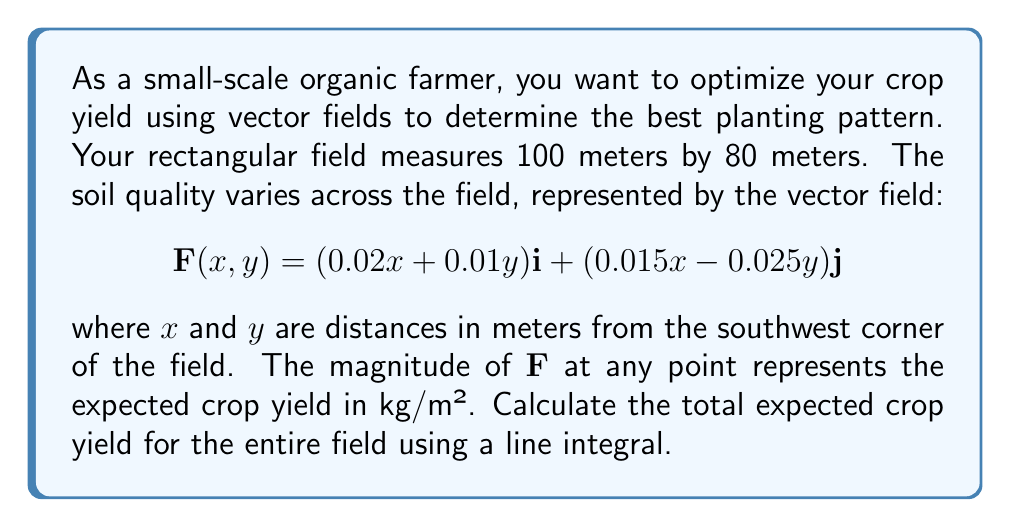Teach me how to tackle this problem. To solve this problem, we need to calculate the flux of the vector field $\mathbf{F}$ across the boundary of the rectangular field. This can be done using the line integral of $\mathbf{F} \cdot \mathbf{n}$ around the perimeter of the field, where $\mathbf{n}$ is the outward unit normal vector.

Steps:

1) The field is a rectangle with corners at (0,0), (100,0), (100,80), and (0,80).

2) We need to evaluate the line integral:

   $$\oint_C \mathbf{F} \cdot \mathbf{n} \, ds$$

3) We can break this into four line integrals, one for each side of the rectangle:

   $$\int_0^{100} F_x(x,0) \, dx + \int_0^{80} F_y(100,y) \, dy - \int_0^{100} F_x(x,80) \, dx - \int_0^{80} F_y(0,y) \, dy$$

4) Let's evaluate each integral:

   Bottom edge: $\int_0^{100} (0.02x) \, dx = [0.01x^2]_0^{100} = 100$

   Right edge: $\int_0^{80} (1.5 - 0.025y) \, dy = [1.5y - 0.0125y^2]_0^{80} = 80$

   Top edge: $-\int_0^{100} (0.02x + 0.8) \, dx = -[0.01x^2 + 0.8x]_0^{100} = -180$

   Left edge: $-\int_0^{80} (-0.025y) \, dy = -[-0.0125y^2]_0^{80} = 80$

5) Sum up all the integrals:

   Total = 100 + 80 - 180 + 80 = 80

Therefore, the total expected crop yield for the entire field is 80 kg.
Answer: The total expected crop yield for the entire field is 80 kg. 